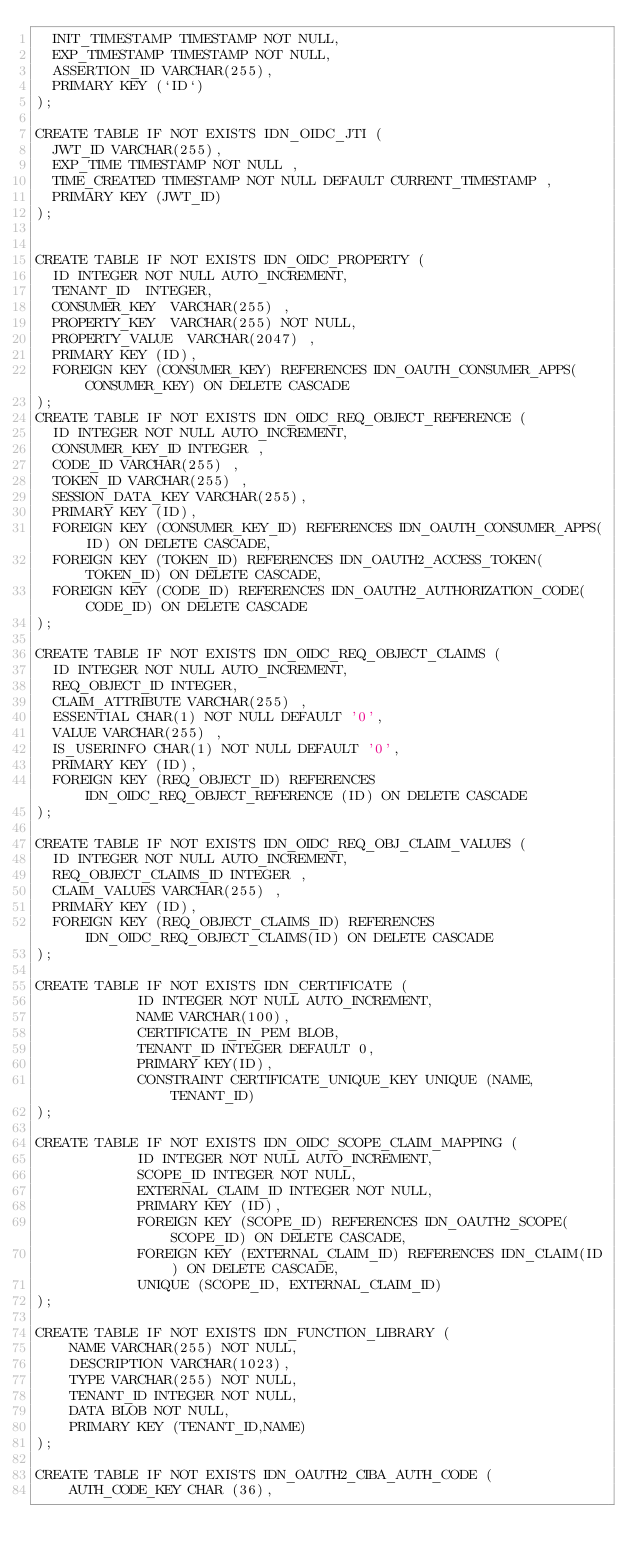Convert code to text. <code><loc_0><loc_0><loc_500><loc_500><_SQL_>  INIT_TIMESTAMP TIMESTAMP NOT NULL,
  EXP_TIMESTAMP TIMESTAMP NOT NULL,
  ASSERTION_ID VARCHAR(255),
  PRIMARY KEY (`ID`)
);

CREATE TABLE IF NOT EXISTS IDN_OIDC_JTI (
  JWT_ID VARCHAR(255),
  EXP_TIME TIMESTAMP NOT NULL ,
  TIME_CREATED TIMESTAMP NOT NULL DEFAULT CURRENT_TIMESTAMP ,
  PRIMARY KEY (JWT_ID)
);


CREATE TABLE IF NOT EXISTS IDN_OIDC_PROPERTY (
  ID INTEGER NOT NULL AUTO_INCREMENT,
  TENANT_ID  INTEGER,
  CONSUMER_KEY  VARCHAR(255) ,
  PROPERTY_KEY  VARCHAR(255) NOT NULL,
  PROPERTY_VALUE  VARCHAR(2047) ,
  PRIMARY KEY (ID),
  FOREIGN KEY (CONSUMER_KEY) REFERENCES IDN_OAUTH_CONSUMER_APPS(CONSUMER_KEY) ON DELETE CASCADE
);
CREATE TABLE IF NOT EXISTS IDN_OIDC_REQ_OBJECT_REFERENCE (
  ID INTEGER NOT NULL AUTO_INCREMENT,
  CONSUMER_KEY_ID INTEGER ,
  CODE_ID VARCHAR(255) ,
  TOKEN_ID VARCHAR(255) ,
  SESSION_DATA_KEY VARCHAR(255),
  PRIMARY KEY (ID),
  FOREIGN KEY (CONSUMER_KEY_ID) REFERENCES IDN_OAUTH_CONSUMER_APPS(ID) ON DELETE CASCADE,
  FOREIGN KEY (TOKEN_ID) REFERENCES IDN_OAUTH2_ACCESS_TOKEN(TOKEN_ID) ON DELETE CASCADE,
  FOREIGN KEY (CODE_ID) REFERENCES IDN_OAUTH2_AUTHORIZATION_CODE(CODE_ID) ON DELETE CASCADE
);

CREATE TABLE IF NOT EXISTS IDN_OIDC_REQ_OBJECT_CLAIMS (
  ID INTEGER NOT NULL AUTO_INCREMENT,
  REQ_OBJECT_ID INTEGER,
  CLAIM_ATTRIBUTE VARCHAR(255) ,
  ESSENTIAL CHAR(1) NOT NULL DEFAULT '0',
  VALUE VARCHAR(255) ,
  IS_USERINFO CHAR(1) NOT NULL DEFAULT '0',
  PRIMARY KEY (ID),
  FOREIGN KEY (REQ_OBJECT_ID) REFERENCES IDN_OIDC_REQ_OBJECT_REFERENCE (ID) ON DELETE CASCADE
);

CREATE TABLE IF NOT EXISTS IDN_OIDC_REQ_OBJ_CLAIM_VALUES (
  ID INTEGER NOT NULL AUTO_INCREMENT,
  REQ_OBJECT_CLAIMS_ID INTEGER ,
  CLAIM_VALUES VARCHAR(255) ,
  PRIMARY KEY (ID),
  FOREIGN KEY (REQ_OBJECT_CLAIMS_ID) REFERENCES  IDN_OIDC_REQ_OBJECT_CLAIMS(ID) ON DELETE CASCADE
);

CREATE TABLE IF NOT EXISTS IDN_CERTIFICATE (
            ID INTEGER NOT NULL AUTO_INCREMENT,
            NAME VARCHAR(100),
            CERTIFICATE_IN_PEM BLOB,
            TENANT_ID INTEGER DEFAULT 0,
            PRIMARY KEY(ID),
            CONSTRAINT CERTIFICATE_UNIQUE_KEY UNIQUE (NAME, TENANT_ID)
);

CREATE TABLE IF NOT EXISTS IDN_OIDC_SCOPE_CLAIM_MAPPING (
            ID INTEGER NOT NULL AUTO_INCREMENT,
            SCOPE_ID INTEGER NOT NULL,
            EXTERNAL_CLAIM_ID INTEGER NOT NULL,
            PRIMARY KEY (ID),
            FOREIGN KEY (SCOPE_ID) REFERENCES IDN_OAUTH2_SCOPE(SCOPE_ID) ON DELETE CASCADE,
            FOREIGN KEY (EXTERNAL_CLAIM_ID) REFERENCES IDN_CLAIM(ID) ON DELETE CASCADE,
            UNIQUE (SCOPE_ID, EXTERNAL_CLAIM_ID)
);

CREATE TABLE IF NOT EXISTS IDN_FUNCTION_LIBRARY (
	NAME VARCHAR(255) NOT NULL,
	DESCRIPTION VARCHAR(1023),
	TYPE VARCHAR(255) NOT NULL,
	TENANT_ID INTEGER NOT NULL,
	DATA BLOB NOT NULL,
	PRIMARY KEY (TENANT_ID,NAME)
);

CREATE TABLE IF NOT EXISTS IDN_OAUTH2_CIBA_AUTH_CODE (
    AUTH_CODE_KEY CHAR (36),</code> 